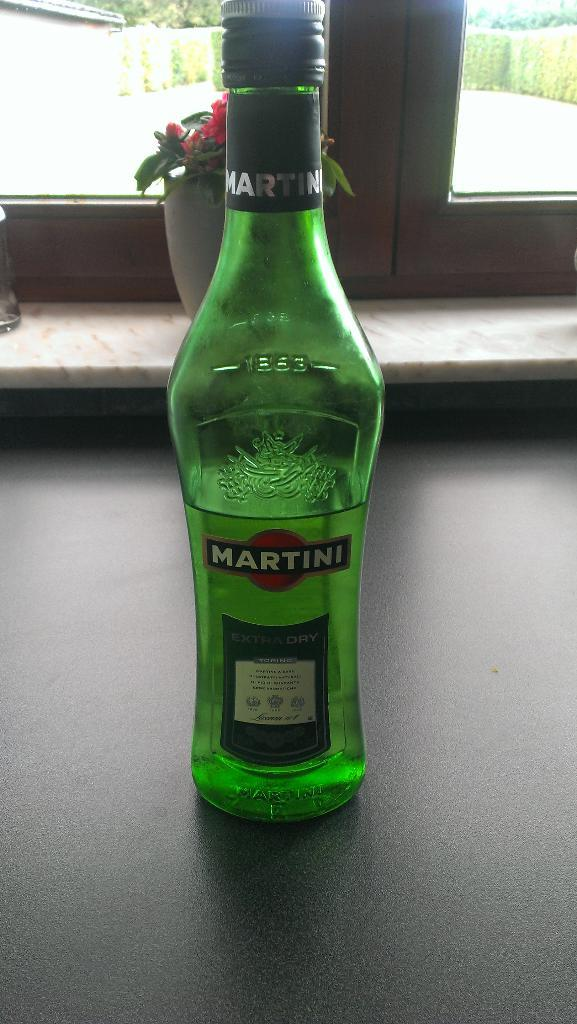<image>
Present a compact description of the photo's key features. A green bottle that says Martini is sitting on a counter. 